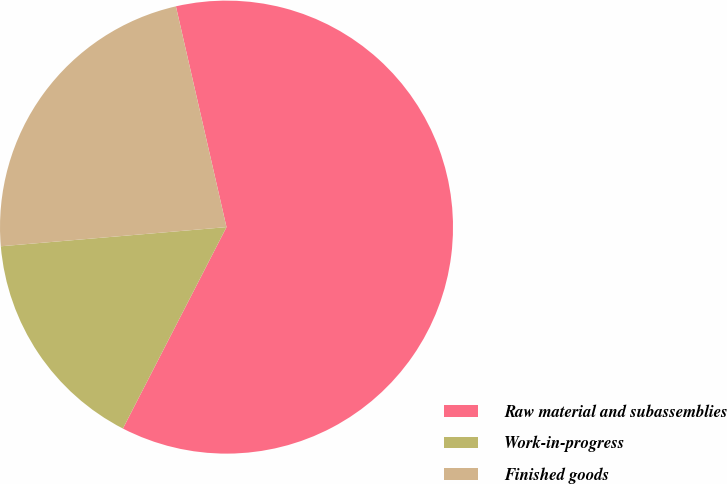Convert chart. <chart><loc_0><loc_0><loc_500><loc_500><pie_chart><fcel>Raw material and subassemblies<fcel>Work-in-progress<fcel>Finished goods<nl><fcel>61.14%<fcel>16.09%<fcel>22.76%<nl></chart> 